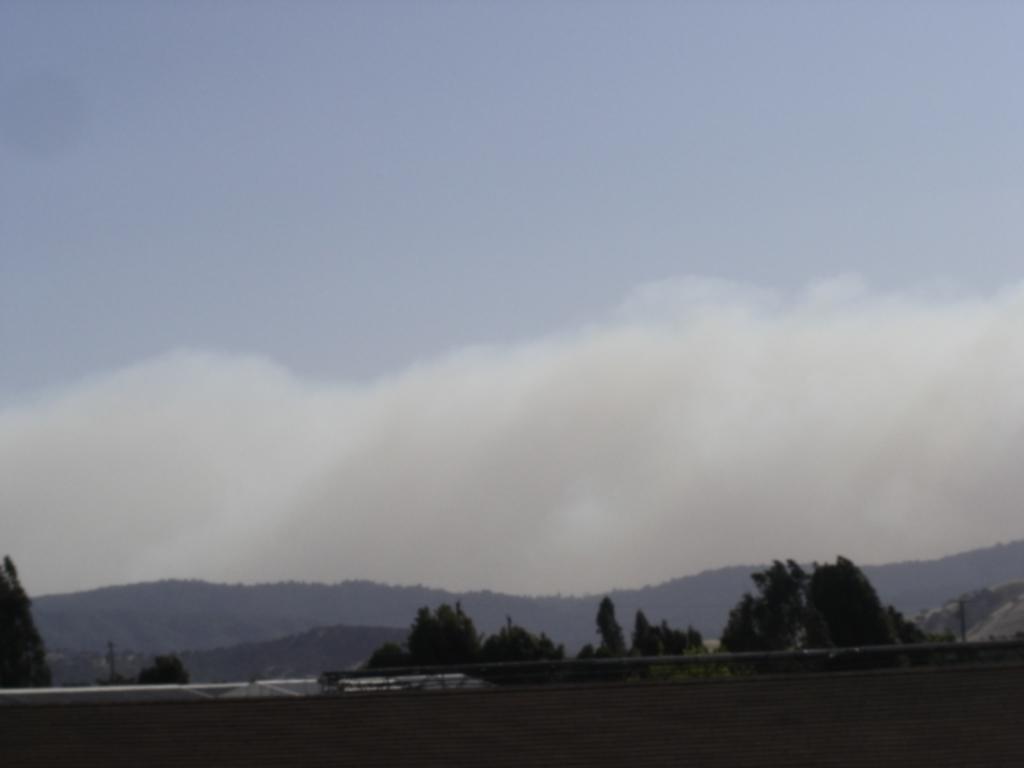In one or two sentences, can you explain what this image depicts? In this image at the bottom there is a wall and pole, and in the background there are some mountains and trees. On the top of the image there is sky. 